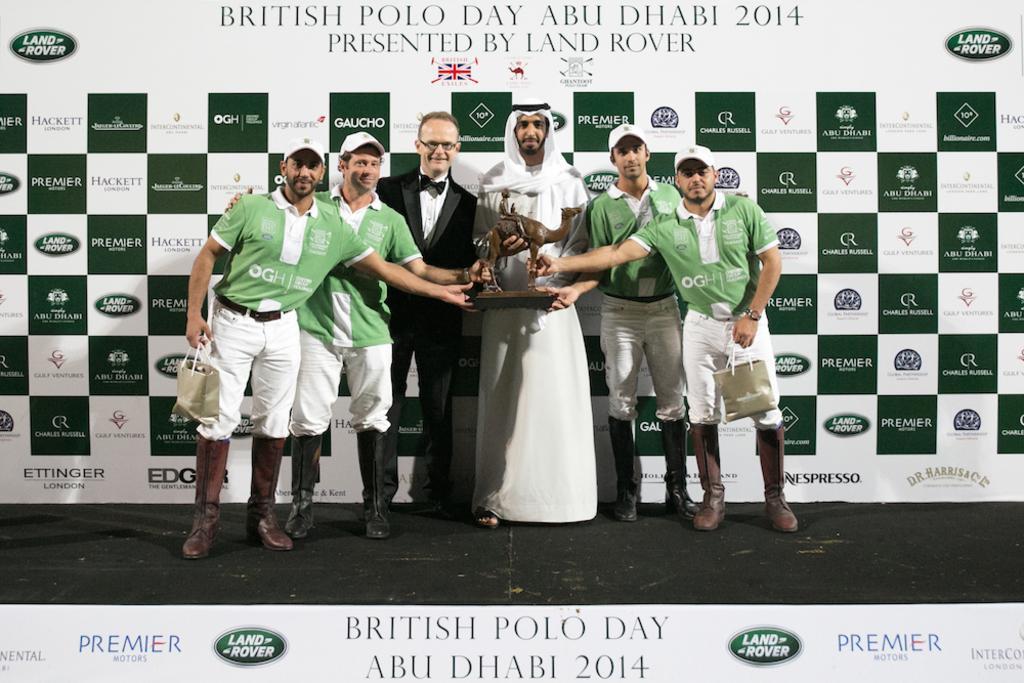In one or two sentences, can you explain what this image depicts? Here in this picture we can see a group of men standing over a place and four of them are wearing caps and one man in the middle is wearing a tuxedo and beside him we can see a man wearing a traditional dress and all of them are smiling and they are holding a trophy in their hands and behind them we can see a banner present. 